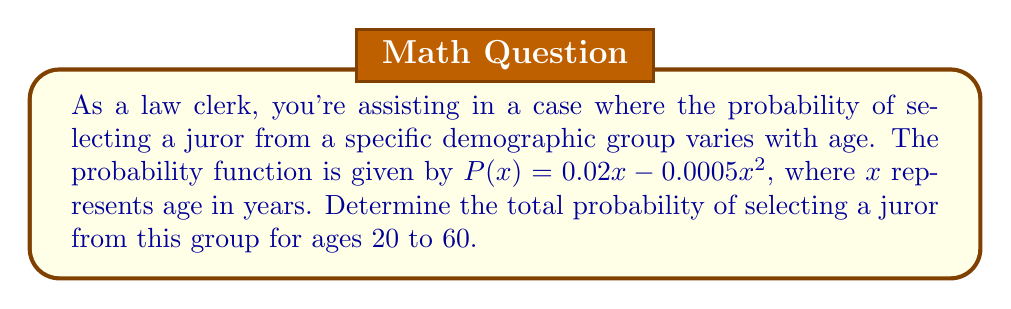Teach me how to tackle this problem. To solve this problem, we need to find the area under the curve of $P(x)$ from $x=20$ to $x=60$. This can be done using definite integration.

1) The given probability function is:
   $P(x) = 0.02x - 0.0005x^2$

2) We need to integrate this function from 20 to 60:
   $$\int_{20}^{60} (0.02x - 0.0005x^2) dx$$

3) Let's integrate term by term:
   $$\int_{20}^{60} 0.02x dx - \int_{20}^{60} 0.0005x^2 dx$$

4) Integrating:
   $$[0.01x^2]_{20}^{60} - [\frac{0.0005x^3}{3}]_{20}^{60}$$

5) Evaluating the definite integral:
   $$(0.01(60^2) - 0.01(20^2)) - (\frac{0.0005(60^3)}{3} - \frac{0.0005(20^3)}{3})$$

6) Simplifying:
   $$(36 - 4) - (36 - 1.333)$$
   $$32 - 34.667$$
   $$-2.667$$

7) Since probability cannot be negative, we interpret this as the area under the curve, which is positive:
   $$2.667$$

This represents the total probability of selecting a juror from the specified demographic group for ages 20 to 60.
Answer: 2.667 